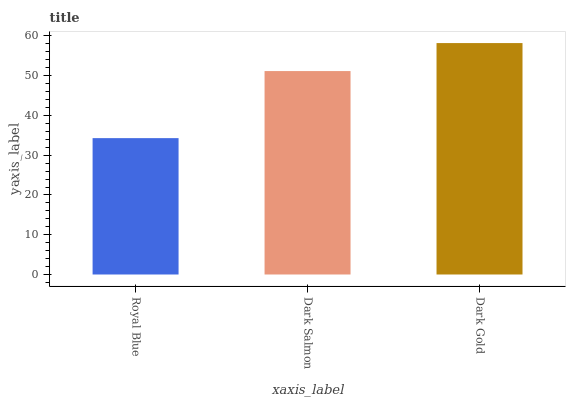Is Royal Blue the minimum?
Answer yes or no. Yes. Is Dark Gold the maximum?
Answer yes or no. Yes. Is Dark Salmon the minimum?
Answer yes or no. No. Is Dark Salmon the maximum?
Answer yes or no. No. Is Dark Salmon greater than Royal Blue?
Answer yes or no. Yes. Is Royal Blue less than Dark Salmon?
Answer yes or no. Yes. Is Royal Blue greater than Dark Salmon?
Answer yes or no. No. Is Dark Salmon less than Royal Blue?
Answer yes or no. No. Is Dark Salmon the high median?
Answer yes or no. Yes. Is Dark Salmon the low median?
Answer yes or no. Yes. Is Royal Blue the high median?
Answer yes or no. No. Is Dark Gold the low median?
Answer yes or no. No. 